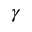Convert formula to latex. <formula><loc_0><loc_0><loc_500><loc_500>\gamma</formula> 